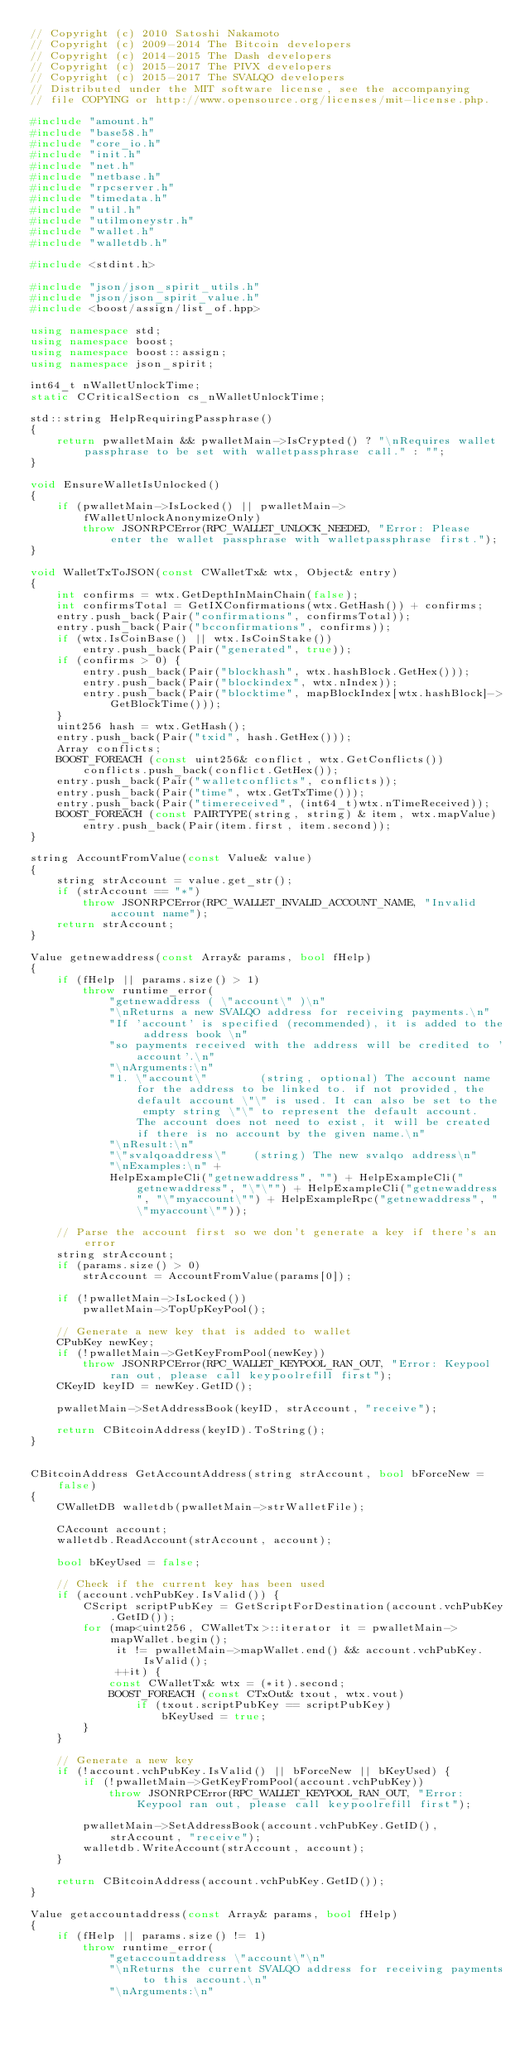Convert code to text. <code><loc_0><loc_0><loc_500><loc_500><_C++_>// Copyright (c) 2010 Satoshi Nakamoto
// Copyright (c) 2009-2014 The Bitcoin developers
// Copyright (c) 2014-2015 The Dash developers
// Copyright (c) 2015-2017 The PIVX developers 
// Copyright (c) 2015-2017 The SVALQO developers
// Distributed under the MIT software license, see the accompanying
// file COPYING or http://www.opensource.org/licenses/mit-license.php.

#include "amount.h"
#include "base58.h"
#include "core_io.h"
#include "init.h"
#include "net.h"
#include "netbase.h"
#include "rpcserver.h"
#include "timedata.h"
#include "util.h"
#include "utilmoneystr.h"
#include "wallet.h"
#include "walletdb.h"

#include <stdint.h>

#include "json/json_spirit_utils.h"
#include "json/json_spirit_value.h"
#include <boost/assign/list_of.hpp>

using namespace std;
using namespace boost;
using namespace boost::assign;
using namespace json_spirit;

int64_t nWalletUnlockTime;
static CCriticalSection cs_nWalletUnlockTime;

std::string HelpRequiringPassphrase()
{
    return pwalletMain && pwalletMain->IsCrypted() ? "\nRequires wallet passphrase to be set with walletpassphrase call." : "";
}

void EnsureWalletIsUnlocked()
{
    if (pwalletMain->IsLocked() || pwalletMain->fWalletUnlockAnonymizeOnly)
        throw JSONRPCError(RPC_WALLET_UNLOCK_NEEDED, "Error: Please enter the wallet passphrase with walletpassphrase first.");
}

void WalletTxToJSON(const CWalletTx& wtx, Object& entry)
{
    int confirms = wtx.GetDepthInMainChain(false);
    int confirmsTotal = GetIXConfirmations(wtx.GetHash()) + confirms;
    entry.push_back(Pair("confirmations", confirmsTotal));
    entry.push_back(Pair("bcconfirmations", confirms));
    if (wtx.IsCoinBase() || wtx.IsCoinStake())
        entry.push_back(Pair("generated", true));
    if (confirms > 0) {
        entry.push_back(Pair("blockhash", wtx.hashBlock.GetHex()));
        entry.push_back(Pair("blockindex", wtx.nIndex));
        entry.push_back(Pair("blocktime", mapBlockIndex[wtx.hashBlock]->GetBlockTime()));
    }
    uint256 hash = wtx.GetHash();
    entry.push_back(Pair("txid", hash.GetHex()));
    Array conflicts;
    BOOST_FOREACH (const uint256& conflict, wtx.GetConflicts())
        conflicts.push_back(conflict.GetHex());
    entry.push_back(Pair("walletconflicts", conflicts));
    entry.push_back(Pair("time", wtx.GetTxTime()));
    entry.push_back(Pair("timereceived", (int64_t)wtx.nTimeReceived));
    BOOST_FOREACH (const PAIRTYPE(string, string) & item, wtx.mapValue)
        entry.push_back(Pair(item.first, item.second));
}

string AccountFromValue(const Value& value)
{
    string strAccount = value.get_str();
    if (strAccount == "*")
        throw JSONRPCError(RPC_WALLET_INVALID_ACCOUNT_NAME, "Invalid account name");
    return strAccount;
}

Value getnewaddress(const Array& params, bool fHelp)
{
    if (fHelp || params.size() > 1)
        throw runtime_error(
            "getnewaddress ( \"account\" )\n"
            "\nReturns a new SVALQO address for receiving payments.\n"
            "If 'account' is specified (recommended), it is added to the address book \n"
            "so payments received with the address will be credited to 'account'.\n"
            "\nArguments:\n"
            "1. \"account\"        (string, optional) The account name for the address to be linked to. if not provided, the default account \"\" is used. It can also be set to the empty string \"\" to represent the default account. The account does not need to exist, it will be created if there is no account by the given name.\n"
            "\nResult:\n"
            "\"svalqoaddress\"    (string) The new svalqo address\n"
            "\nExamples:\n" +
            HelpExampleCli("getnewaddress", "") + HelpExampleCli("getnewaddress", "\"\"") + HelpExampleCli("getnewaddress", "\"myaccount\"") + HelpExampleRpc("getnewaddress", "\"myaccount\""));

    // Parse the account first so we don't generate a key if there's an error
    string strAccount;
    if (params.size() > 0)
        strAccount = AccountFromValue(params[0]);

    if (!pwalletMain->IsLocked())
        pwalletMain->TopUpKeyPool();

    // Generate a new key that is added to wallet
    CPubKey newKey;
    if (!pwalletMain->GetKeyFromPool(newKey))
        throw JSONRPCError(RPC_WALLET_KEYPOOL_RAN_OUT, "Error: Keypool ran out, please call keypoolrefill first");
    CKeyID keyID = newKey.GetID();

    pwalletMain->SetAddressBook(keyID, strAccount, "receive");

    return CBitcoinAddress(keyID).ToString();
}


CBitcoinAddress GetAccountAddress(string strAccount, bool bForceNew = false)
{
    CWalletDB walletdb(pwalletMain->strWalletFile);

    CAccount account;
    walletdb.ReadAccount(strAccount, account);

    bool bKeyUsed = false;

    // Check if the current key has been used
    if (account.vchPubKey.IsValid()) {
        CScript scriptPubKey = GetScriptForDestination(account.vchPubKey.GetID());
        for (map<uint256, CWalletTx>::iterator it = pwalletMain->mapWallet.begin();
             it != pwalletMain->mapWallet.end() && account.vchPubKey.IsValid();
             ++it) {
            const CWalletTx& wtx = (*it).second;
            BOOST_FOREACH (const CTxOut& txout, wtx.vout)
                if (txout.scriptPubKey == scriptPubKey)
                    bKeyUsed = true;
        }
    }

    // Generate a new key
    if (!account.vchPubKey.IsValid() || bForceNew || bKeyUsed) {
        if (!pwalletMain->GetKeyFromPool(account.vchPubKey))
            throw JSONRPCError(RPC_WALLET_KEYPOOL_RAN_OUT, "Error: Keypool ran out, please call keypoolrefill first");

        pwalletMain->SetAddressBook(account.vchPubKey.GetID(), strAccount, "receive");
        walletdb.WriteAccount(strAccount, account);
    }

    return CBitcoinAddress(account.vchPubKey.GetID());
}

Value getaccountaddress(const Array& params, bool fHelp)
{
    if (fHelp || params.size() != 1)
        throw runtime_error(
            "getaccountaddress \"account\"\n"
            "\nReturns the current SVALQO address for receiving payments to this account.\n"
            "\nArguments:\n"</code> 